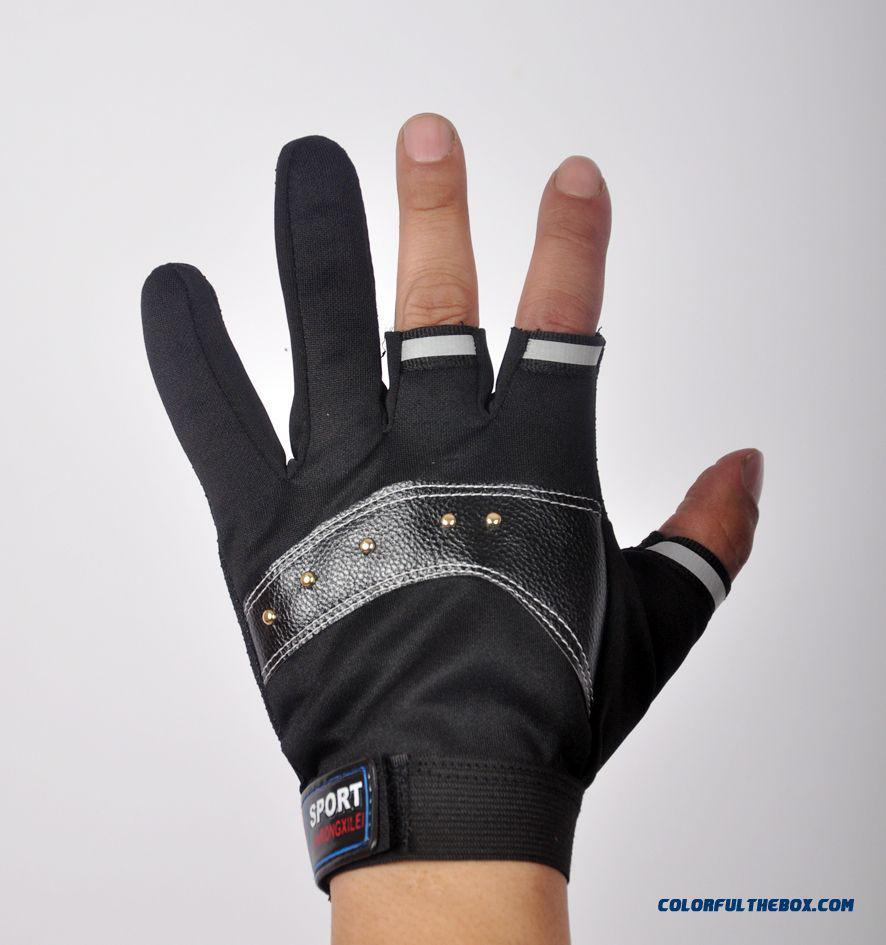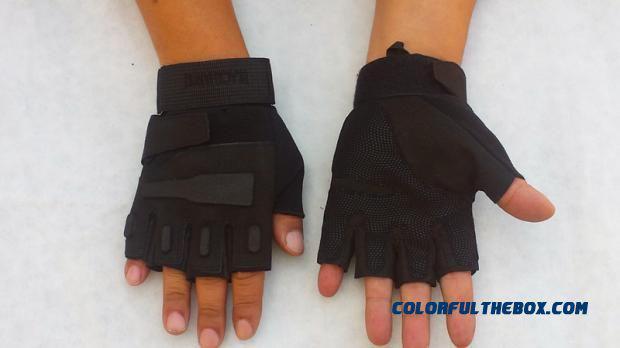The first image is the image on the left, the second image is the image on the right. Given the left and right images, does the statement "One image shows a pair of dark half-finger gloves, and the other image shows a single knitted half-finger glove with a striped pattern." hold true? Answer yes or no. No. The first image is the image on the left, the second image is the image on the right. Analyze the images presented: Is the assertion "A glove is on a single hand in the image on the left." valid? Answer yes or no. Yes. 